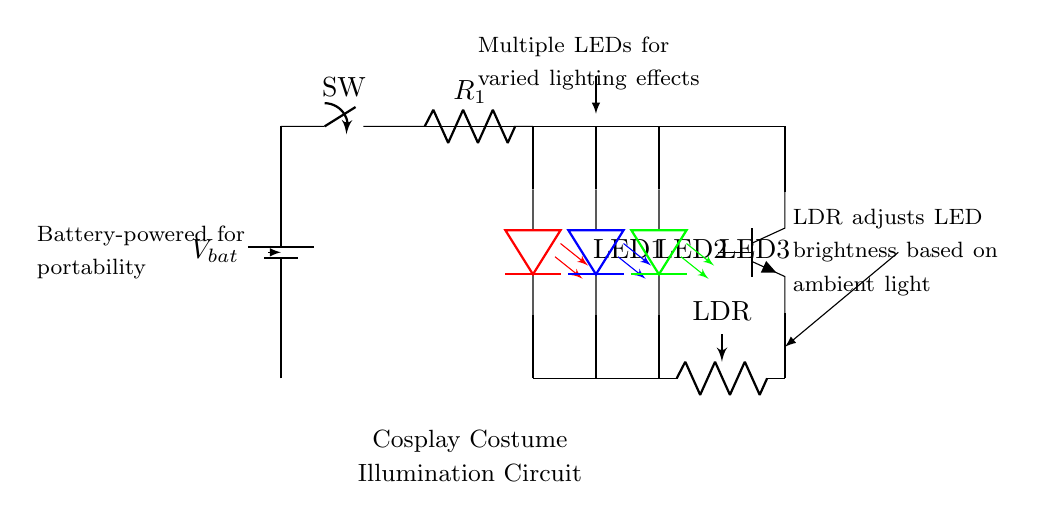What type of circuit is this? This circuit is a hybrid LED and battery-powered circuit designed for cosplay costumes. It utilizes a battery for power and includes LEDs, a photoresistor, and a transistor for illumination.
Answer: hybrid LED and battery-powered circuit How many LEDs are present in the circuit? The circuit diagram shows three LEDs connected in parallel. Each LED is colored differently (red, blue, and green), indicating varied lighting options.
Answer: three What component adjusts the brightness of the LEDs? The component responsible for adjusting the brightness of the LEDs is the light-dependent resistor (LDR), which responds to ambient light levels, making the LEDs brighter or dimmer accordingly.
Answer: LDR What is the purpose of the switch in the circuit? The switch allows the user to easily turn the circuit on or off, controlling whether the LEDs are illuminated or not. This is essential for energy conservation and practicality in cosplay use.
Answer: control LED illumination Which component provides power to the circuit? The battery supplies power to the circuit by providing a voltage difference necessary for the operation of the LEDs and other components within the circuit.
Answer: battery What is the role of the current limiting resistor? The current limiting resistor protects the LEDs by restricting the amount of current flowing through them, preventing damage from excessive current, which can burn out the LEDs.
Answer: restrict current to LEDs What happens when the ambient light increases? When the ambient light increases, the resistance of the photoresistor decreases, causing the transistor to potentially turn off, which reduces the brightness of the LEDs. This automatic adjustment helps maintain proper lighting based on the environment.
Answer: LEDs dim or turn off 